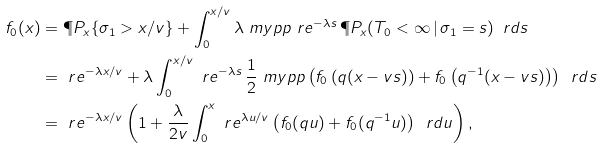<formula> <loc_0><loc_0><loc_500><loc_500>f _ { 0 } ( x ) & = \P P _ { x } \{ \sigma _ { 1 } > x / v \} + \int _ { 0 } ^ { x / v } \lambda \ m y p p \ r e ^ { - \lambda s } \, \P P _ { x } ( T _ { 0 } < \infty \, | \, \sigma _ { 1 } = s ) \, \ r d s \\ & = \ r e ^ { - \lambda x / v } + \lambda \int _ { 0 } ^ { x / v } \ r e ^ { - \lambda s } \, \frac { 1 } { 2 } \ m y p p \left ( f _ { 0 } \left ( q ( x - v s ) \right ) + f _ { 0 } \left ( q ^ { - 1 } ( x - v s ) \right ) \right ) \, \ r d s \\ & = \ r e ^ { - \lambda x / v } \left ( 1 + \frac { \lambda } { 2 v } \int _ { 0 } ^ { x } \ r e ^ { \lambda u / v } \left ( f _ { 0 } ( q u ) + f _ { 0 } ( q ^ { - 1 } u ) \right ) \, \ r d u \right ) ,</formula> 